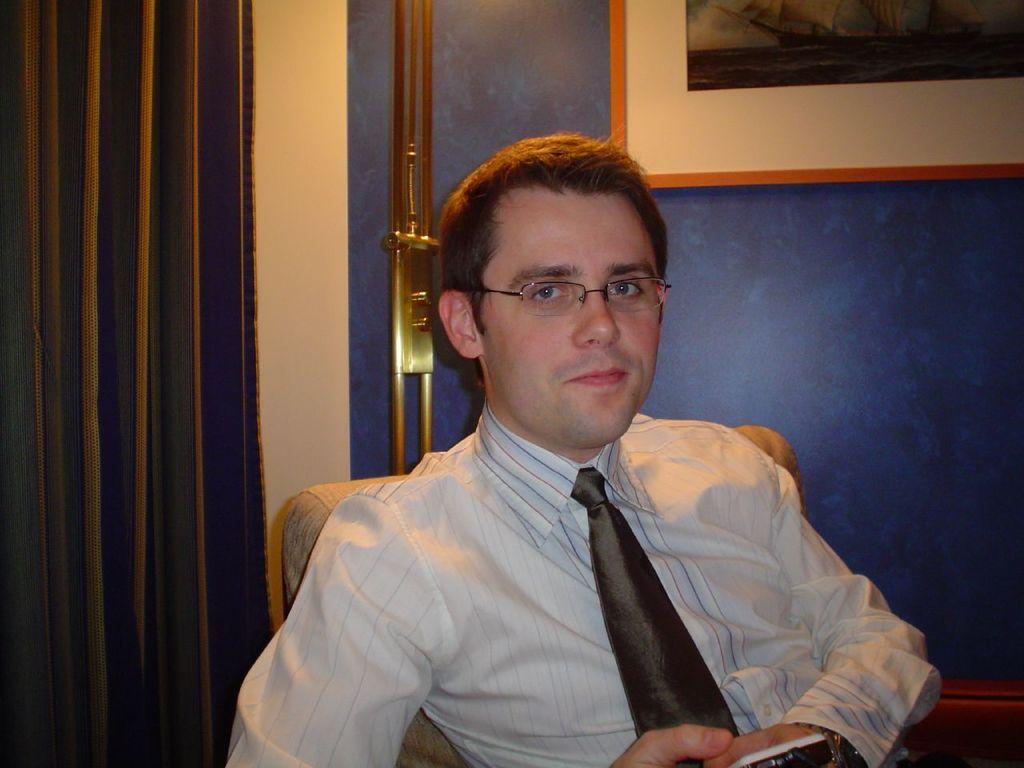What is the man doing in the image? The man is sitting on a chair in the image. Can you describe the man's appearance? The man is wearing specs in the image. What is the man holding in the image? The man is holding something in the image, but we cannot determine what it is from the facts provided. What color is the wall behind the man? There is a blue wall in the background of the image. What is hanging on the wall? There is a photo frame on the wall in the image. How many bridges can be seen in the image? There are no bridges present in the image. What is the drop in temperature after the man leaves the room? The facts provided do not give any information about the temperature or the man leaving the room, so we cannot answer this question. 